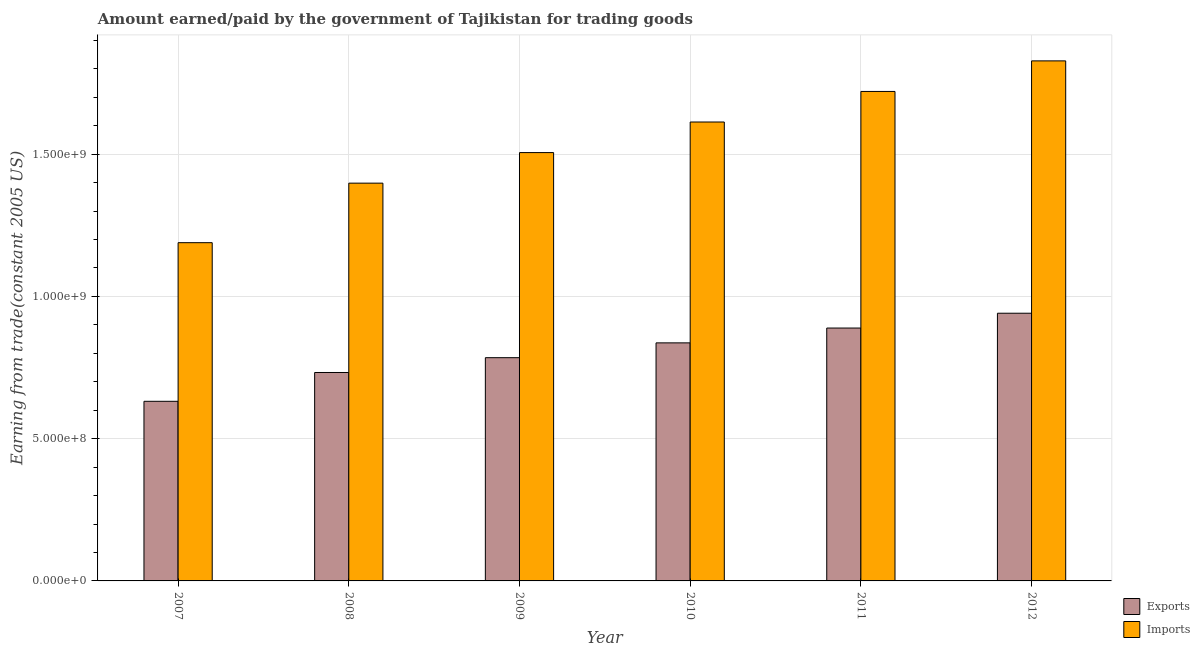Are the number of bars per tick equal to the number of legend labels?
Offer a terse response. Yes. Are the number of bars on each tick of the X-axis equal?
Offer a very short reply. Yes. How many bars are there on the 6th tick from the right?
Provide a short and direct response. 2. What is the label of the 3rd group of bars from the left?
Ensure brevity in your answer.  2009. What is the amount earned from exports in 2010?
Give a very brief answer. 8.37e+08. Across all years, what is the maximum amount paid for imports?
Your answer should be very brief. 1.83e+09. Across all years, what is the minimum amount paid for imports?
Provide a succinct answer. 1.19e+09. What is the total amount earned from exports in the graph?
Offer a very short reply. 4.81e+09. What is the difference between the amount paid for imports in 2010 and that in 2012?
Ensure brevity in your answer.  -2.15e+08. What is the difference between the amount earned from exports in 2012 and the amount paid for imports in 2007?
Provide a succinct answer. 3.10e+08. What is the average amount earned from exports per year?
Ensure brevity in your answer.  8.02e+08. In the year 2007, what is the difference between the amount paid for imports and amount earned from exports?
Your answer should be very brief. 0. What is the ratio of the amount paid for imports in 2007 to that in 2008?
Provide a short and direct response. 0.85. Is the amount earned from exports in 2009 less than that in 2011?
Your answer should be very brief. Yes. Is the difference between the amount earned from exports in 2009 and 2010 greater than the difference between the amount paid for imports in 2009 and 2010?
Give a very brief answer. No. What is the difference between the highest and the second highest amount earned from exports?
Provide a succinct answer. 5.21e+07. What is the difference between the highest and the lowest amount paid for imports?
Your response must be concise. 6.39e+08. In how many years, is the amount paid for imports greater than the average amount paid for imports taken over all years?
Provide a succinct answer. 3. Is the sum of the amount earned from exports in 2007 and 2009 greater than the maximum amount paid for imports across all years?
Provide a succinct answer. Yes. What does the 1st bar from the left in 2007 represents?
Ensure brevity in your answer.  Exports. What does the 1st bar from the right in 2010 represents?
Your response must be concise. Imports. How many bars are there?
Offer a very short reply. 12. Are all the bars in the graph horizontal?
Offer a very short reply. No. How many years are there in the graph?
Your response must be concise. 6. Does the graph contain any zero values?
Ensure brevity in your answer.  No. Where does the legend appear in the graph?
Your answer should be very brief. Bottom right. How many legend labels are there?
Your response must be concise. 2. How are the legend labels stacked?
Keep it short and to the point. Vertical. What is the title of the graph?
Ensure brevity in your answer.  Amount earned/paid by the government of Tajikistan for trading goods. Does "US$" appear as one of the legend labels in the graph?
Your answer should be very brief. No. What is the label or title of the Y-axis?
Your response must be concise. Earning from trade(constant 2005 US). What is the Earning from trade(constant 2005 US) of Exports in 2007?
Make the answer very short. 6.31e+08. What is the Earning from trade(constant 2005 US) of Imports in 2007?
Give a very brief answer. 1.19e+09. What is the Earning from trade(constant 2005 US) of Exports in 2008?
Your answer should be compact. 7.32e+08. What is the Earning from trade(constant 2005 US) in Imports in 2008?
Your answer should be compact. 1.40e+09. What is the Earning from trade(constant 2005 US) of Exports in 2009?
Your response must be concise. 7.85e+08. What is the Earning from trade(constant 2005 US) of Imports in 2009?
Offer a very short reply. 1.51e+09. What is the Earning from trade(constant 2005 US) of Exports in 2010?
Your answer should be very brief. 8.37e+08. What is the Earning from trade(constant 2005 US) in Imports in 2010?
Provide a short and direct response. 1.61e+09. What is the Earning from trade(constant 2005 US) in Exports in 2011?
Keep it short and to the point. 8.89e+08. What is the Earning from trade(constant 2005 US) in Imports in 2011?
Your answer should be compact. 1.72e+09. What is the Earning from trade(constant 2005 US) in Exports in 2012?
Offer a terse response. 9.41e+08. What is the Earning from trade(constant 2005 US) in Imports in 2012?
Offer a terse response. 1.83e+09. Across all years, what is the maximum Earning from trade(constant 2005 US) in Exports?
Your answer should be compact. 9.41e+08. Across all years, what is the maximum Earning from trade(constant 2005 US) in Imports?
Provide a succinct answer. 1.83e+09. Across all years, what is the minimum Earning from trade(constant 2005 US) in Exports?
Your answer should be very brief. 6.31e+08. Across all years, what is the minimum Earning from trade(constant 2005 US) of Imports?
Make the answer very short. 1.19e+09. What is the total Earning from trade(constant 2005 US) of Exports in the graph?
Make the answer very short. 4.81e+09. What is the total Earning from trade(constant 2005 US) of Imports in the graph?
Provide a succinct answer. 9.25e+09. What is the difference between the Earning from trade(constant 2005 US) of Exports in 2007 and that in 2008?
Provide a succinct answer. -1.01e+08. What is the difference between the Earning from trade(constant 2005 US) in Imports in 2007 and that in 2008?
Provide a short and direct response. -2.09e+08. What is the difference between the Earning from trade(constant 2005 US) of Exports in 2007 and that in 2009?
Offer a terse response. -1.53e+08. What is the difference between the Earning from trade(constant 2005 US) of Imports in 2007 and that in 2009?
Provide a succinct answer. -3.17e+08. What is the difference between the Earning from trade(constant 2005 US) of Exports in 2007 and that in 2010?
Offer a terse response. -2.05e+08. What is the difference between the Earning from trade(constant 2005 US) of Imports in 2007 and that in 2010?
Keep it short and to the point. -4.24e+08. What is the difference between the Earning from trade(constant 2005 US) of Exports in 2007 and that in 2011?
Your answer should be compact. -2.57e+08. What is the difference between the Earning from trade(constant 2005 US) in Imports in 2007 and that in 2011?
Your answer should be very brief. -5.32e+08. What is the difference between the Earning from trade(constant 2005 US) of Exports in 2007 and that in 2012?
Make the answer very short. -3.10e+08. What is the difference between the Earning from trade(constant 2005 US) of Imports in 2007 and that in 2012?
Your answer should be very brief. -6.39e+08. What is the difference between the Earning from trade(constant 2005 US) in Exports in 2008 and that in 2009?
Your answer should be compact. -5.21e+07. What is the difference between the Earning from trade(constant 2005 US) of Imports in 2008 and that in 2009?
Provide a succinct answer. -1.07e+08. What is the difference between the Earning from trade(constant 2005 US) in Exports in 2008 and that in 2010?
Keep it short and to the point. -1.04e+08. What is the difference between the Earning from trade(constant 2005 US) of Imports in 2008 and that in 2010?
Provide a short and direct response. -2.15e+08. What is the difference between the Earning from trade(constant 2005 US) in Exports in 2008 and that in 2011?
Your response must be concise. -1.56e+08. What is the difference between the Earning from trade(constant 2005 US) of Imports in 2008 and that in 2011?
Provide a short and direct response. -3.22e+08. What is the difference between the Earning from trade(constant 2005 US) of Exports in 2008 and that in 2012?
Your answer should be very brief. -2.08e+08. What is the difference between the Earning from trade(constant 2005 US) of Imports in 2008 and that in 2012?
Ensure brevity in your answer.  -4.30e+08. What is the difference between the Earning from trade(constant 2005 US) of Exports in 2009 and that in 2010?
Offer a very short reply. -5.21e+07. What is the difference between the Earning from trade(constant 2005 US) in Imports in 2009 and that in 2010?
Your answer should be very brief. -1.07e+08. What is the difference between the Earning from trade(constant 2005 US) in Exports in 2009 and that in 2011?
Provide a succinct answer. -1.04e+08. What is the difference between the Earning from trade(constant 2005 US) of Imports in 2009 and that in 2011?
Your answer should be compact. -2.15e+08. What is the difference between the Earning from trade(constant 2005 US) of Exports in 2009 and that in 2012?
Ensure brevity in your answer.  -1.56e+08. What is the difference between the Earning from trade(constant 2005 US) of Imports in 2009 and that in 2012?
Provide a succinct answer. -3.22e+08. What is the difference between the Earning from trade(constant 2005 US) of Exports in 2010 and that in 2011?
Your answer should be very brief. -5.21e+07. What is the difference between the Earning from trade(constant 2005 US) of Imports in 2010 and that in 2011?
Keep it short and to the point. -1.07e+08. What is the difference between the Earning from trade(constant 2005 US) in Exports in 2010 and that in 2012?
Your answer should be very brief. -1.04e+08. What is the difference between the Earning from trade(constant 2005 US) in Imports in 2010 and that in 2012?
Offer a very short reply. -2.15e+08. What is the difference between the Earning from trade(constant 2005 US) in Exports in 2011 and that in 2012?
Offer a very short reply. -5.21e+07. What is the difference between the Earning from trade(constant 2005 US) in Imports in 2011 and that in 2012?
Your response must be concise. -1.07e+08. What is the difference between the Earning from trade(constant 2005 US) of Exports in 2007 and the Earning from trade(constant 2005 US) of Imports in 2008?
Provide a succinct answer. -7.67e+08. What is the difference between the Earning from trade(constant 2005 US) of Exports in 2007 and the Earning from trade(constant 2005 US) of Imports in 2009?
Give a very brief answer. -8.74e+08. What is the difference between the Earning from trade(constant 2005 US) of Exports in 2007 and the Earning from trade(constant 2005 US) of Imports in 2010?
Give a very brief answer. -9.82e+08. What is the difference between the Earning from trade(constant 2005 US) of Exports in 2007 and the Earning from trade(constant 2005 US) of Imports in 2011?
Give a very brief answer. -1.09e+09. What is the difference between the Earning from trade(constant 2005 US) of Exports in 2007 and the Earning from trade(constant 2005 US) of Imports in 2012?
Give a very brief answer. -1.20e+09. What is the difference between the Earning from trade(constant 2005 US) of Exports in 2008 and the Earning from trade(constant 2005 US) of Imports in 2009?
Ensure brevity in your answer.  -7.73e+08. What is the difference between the Earning from trade(constant 2005 US) of Exports in 2008 and the Earning from trade(constant 2005 US) of Imports in 2010?
Your response must be concise. -8.80e+08. What is the difference between the Earning from trade(constant 2005 US) in Exports in 2008 and the Earning from trade(constant 2005 US) in Imports in 2011?
Make the answer very short. -9.88e+08. What is the difference between the Earning from trade(constant 2005 US) of Exports in 2008 and the Earning from trade(constant 2005 US) of Imports in 2012?
Your answer should be very brief. -1.10e+09. What is the difference between the Earning from trade(constant 2005 US) of Exports in 2009 and the Earning from trade(constant 2005 US) of Imports in 2010?
Your answer should be very brief. -8.28e+08. What is the difference between the Earning from trade(constant 2005 US) of Exports in 2009 and the Earning from trade(constant 2005 US) of Imports in 2011?
Ensure brevity in your answer.  -9.36e+08. What is the difference between the Earning from trade(constant 2005 US) in Exports in 2009 and the Earning from trade(constant 2005 US) in Imports in 2012?
Make the answer very short. -1.04e+09. What is the difference between the Earning from trade(constant 2005 US) of Exports in 2010 and the Earning from trade(constant 2005 US) of Imports in 2011?
Your answer should be compact. -8.84e+08. What is the difference between the Earning from trade(constant 2005 US) in Exports in 2010 and the Earning from trade(constant 2005 US) in Imports in 2012?
Your answer should be compact. -9.91e+08. What is the difference between the Earning from trade(constant 2005 US) of Exports in 2011 and the Earning from trade(constant 2005 US) of Imports in 2012?
Keep it short and to the point. -9.39e+08. What is the average Earning from trade(constant 2005 US) in Exports per year?
Give a very brief answer. 8.02e+08. What is the average Earning from trade(constant 2005 US) in Imports per year?
Give a very brief answer. 1.54e+09. In the year 2007, what is the difference between the Earning from trade(constant 2005 US) in Exports and Earning from trade(constant 2005 US) in Imports?
Your response must be concise. -5.57e+08. In the year 2008, what is the difference between the Earning from trade(constant 2005 US) in Exports and Earning from trade(constant 2005 US) in Imports?
Offer a very short reply. -6.65e+08. In the year 2009, what is the difference between the Earning from trade(constant 2005 US) of Exports and Earning from trade(constant 2005 US) of Imports?
Give a very brief answer. -7.21e+08. In the year 2010, what is the difference between the Earning from trade(constant 2005 US) in Exports and Earning from trade(constant 2005 US) in Imports?
Keep it short and to the point. -7.76e+08. In the year 2011, what is the difference between the Earning from trade(constant 2005 US) of Exports and Earning from trade(constant 2005 US) of Imports?
Provide a short and direct response. -8.31e+08. In the year 2012, what is the difference between the Earning from trade(constant 2005 US) of Exports and Earning from trade(constant 2005 US) of Imports?
Ensure brevity in your answer.  -8.87e+08. What is the ratio of the Earning from trade(constant 2005 US) of Exports in 2007 to that in 2008?
Offer a terse response. 0.86. What is the ratio of the Earning from trade(constant 2005 US) of Imports in 2007 to that in 2008?
Your answer should be very brief. 0.85. What is the ratio of the Earning from trade(constant 2005 US) in Exports in 2007 to that in 2009?
Keep it short and to the point. 0.8. What is the ratio of the Earning from trade(constant 2005 US) in Imports in 2007 to that in 2009?
Offer a very short reply. 0.79. What is the ratio of the Earning from trade(constant 2005 US) in Exports in 2007 to that in 2010?
Make the answer very short. 0.75. What is the ratio of the Earning from trade(constant 2005 US) of Imports in 2007 to that in 2010?
Offer a terse response. 0.74. What is the ratio of the Earning from trade(constant 2005 US) of Exports in 2007 to that in 2011?
Your answer should be very brief. 0.71. What is the ratio of the Earning from trade(constant 2005 US) of Imports in 2007 to that in 2011?
Make the answer very short. 0.69. What is the ratio of the Earning from trade(constant 2005 US) in Exports in 2007 to that in 2012?
Your response must be concise. 0.67. What is the ratio of the Earning from trade(constant 2005 US) in Imports in 2007 to that in 2012?
Provide a succinct answer. 0.65. What is the ratio of the Earning from trade(constant 2005 US) of Exports in 2008 to that in 2009?
Offer a terse response. 0.93. What is the ratio of the Earning from trade(constant 2005 US) in Imports in 2008 to that in 2009?
Provide a succinct answer. 0.93. What is the ratio of the Earning from trade(constant 2005 US) of Exports in 2008 to that in 2010?
Make the answer very short. 0.88. What is the ratio of the Earning from trade(constant 2005 US) of Imports in 2008 to that in 2010?
Keep it short and to the point. 0.87. What is the ratio of the Earning from trade(constant 2005 US) in Exports in 2008 to that in 2011?
Your answer should be very brief. 0.82. What is the ratio of the Earning from trade(constant 2005 US) of Imports in 2008 to that in 2011?
Your answer should be compact. 0.81. What is the ratio of the Earning from trade(constant 2005 US) of Exports in 2008 to that in 2012?
Your answer should be compact. 0.78. What is the ratio of the Earning from trade(constant 2005 US) in Imports in 2008 to that in 2012?
Your answer should be very brief. 0.76. What is the ratio of the Earning from trade(constant 2005 US) of Exports in 2009 to that in 2010?
Your response must be concise. 0.94. What is the ratio of the Earning from trade(constant 2005 US) in Imports in 2009 to that in 2010?
Your answer should be compact. 0.93. What is the ratio of the Earning from trade(constant 2005 US) in Exports in 2009 to that in 2011?
Your response must be concise. 0.88. What is the ratio of the Earning from trade(constant 2005 US) of Imports in 2009 to that in 2011?
Ensure brevity in your answer.  0.88. What is the ratio of the Earning from trade(constant 2005 US) in Exports in 2009 to that in 2012?
Your answer should be compact. 0.83. What is the ratio of the Earning from trade(constant 2005 US) of Imports in 2009 to that in 2012?
Provide a succinct answer. 0.82. What is the ratio of the Earning from trade(constant 2005 US) in Exports in 2010 to that in 2011?
Your answer should be compact. 0.94. What is the ratio of the Earning from trade(constant 2005 US) of Imports in 2010 to that in 2011?
Give a very brief answer. 0.94. What is the ratio of the Earning from trade(constant 2005 US) of Exports in 2010 to that in 2012?
Give a very brief answer. 0.89. What is the ratio of the Earning from trade(constant 2005 US) of Imports in 2010 to that in 2012?
Offer a terse response. 0.88. What is the ratio of the Earning from trade(constant 2005 US) of Exports in 2011 to that in 2012?
Offer a very short reply. 0.94. What is the difference between the highest and the second highest Earning from trade(constant 2005 US) in Exports?
Give a very brief answer. 5.21e+07. What is the difference between the highest and the second highest Earning from trade(constant 2005 US) in Imports?
Ensure brevity in your answer.  1.07e+08. What is the difference between the highest and the lowest Earning from trade(constant 2005 US) of Exports?
Your response must be concise. 3.10e+08. What is the difference between the highest and the lowest Earning from trade(constant 2005 US) of Imports?
Make the answer very short. 6.39e+08. 